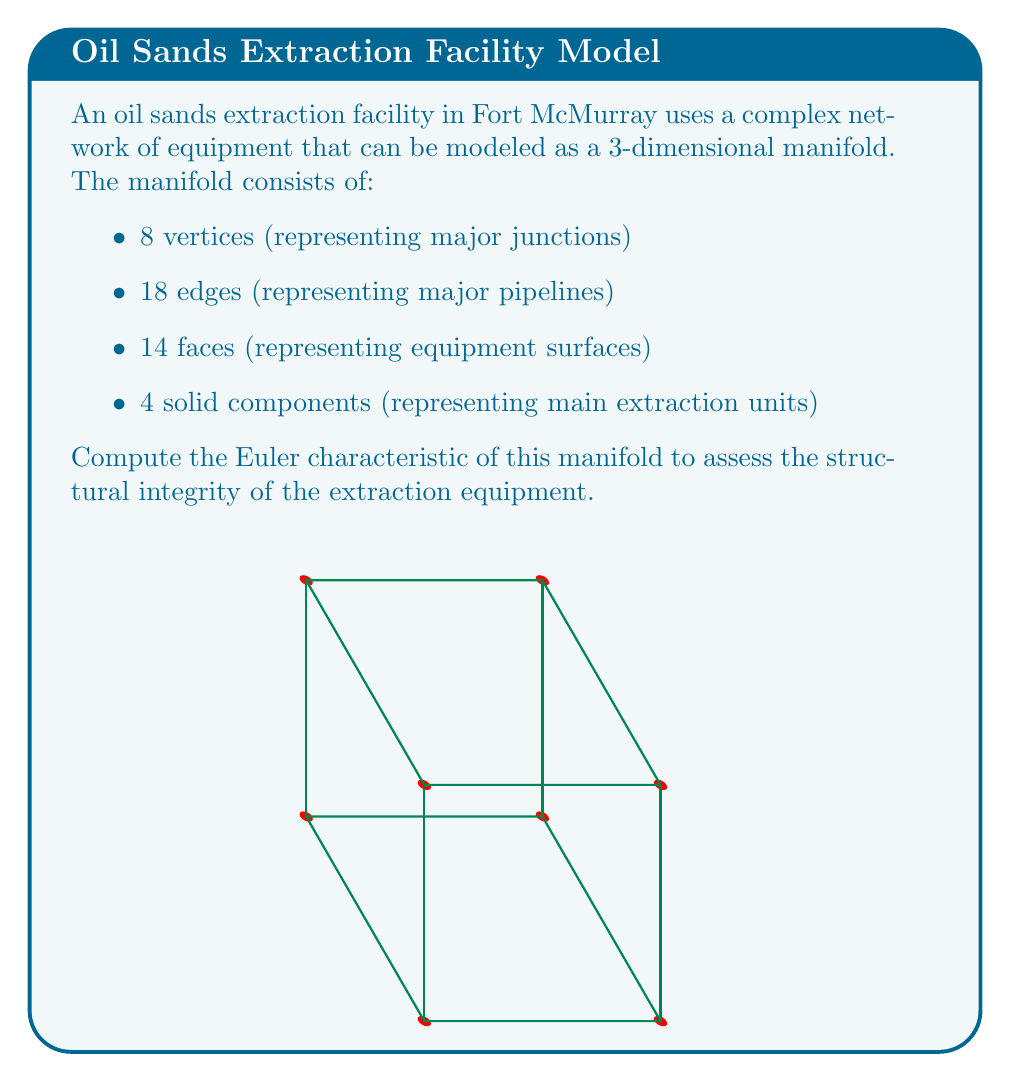Can you solve this math problem? To compute the Euler characteristic of the manifold, we'll use the formula:

$$\chi = V - E + F - S$$

Where:
$V$ = number of vertices
$E$ = number of edges
$F$ = number of faces
$S$ = number of solid components

Given:
$V = 8$
$E = 18$
$F = 14$
$S = 4$

Let's substitute these values into the formula:

$$\begin{align}
\chi &= V - E + F - S \\
&= 8 - 18 + 14 - 4 \\
&= 0
\end{align}$$

The Euler characteristic of this manifold is 0.

Interpretation for Fort McMurray residents:
A zero Euler characteristic suggests that the equipment network has a balanced structure, similar to a torus or donut shape. This indicates a robust and interconnected system, which is crucial for the reliable operation of oil sands extraction equipment in the challenging conditions of Fort McMurray.
Answer: $\chi = 0$ 